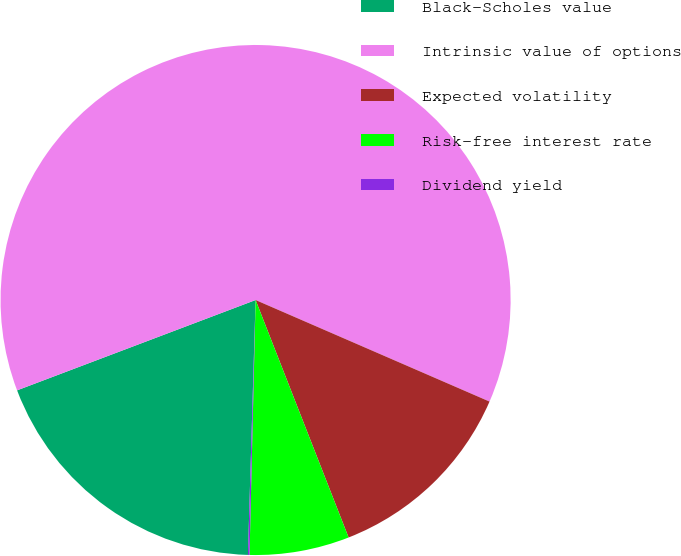Convert chart to OTSL. <chart><loc_0><loc_0><loc_500><loc_500><pie_chart><fcel>Black-Scholes value<fcel>Intrinsic value of options<fcel>Expected volatility<fcel>Risk-free interest rate<fcel>Dividend yield<nl><fcel>18.76%<fcel>62.28%<fcel>12.54%<fcel>6.32%<fcel>0.1%<nl></chart> 